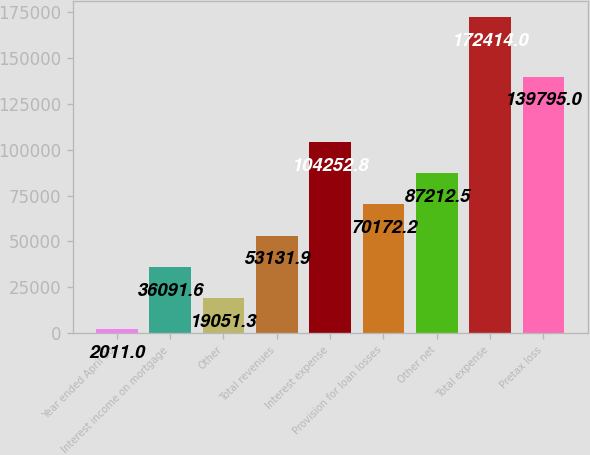Convert chart. <chart><loc_0><loc_0><loc_500><loc_500><bar_chart><fcel>Year ended April 30<fcel>Interest income on mortgage<fcel>Other<fcel>Total revenues<fcel>Interest expense<fcel>Provision for loan losses<fcel>Other net<fcel>Total expense<fcel>Pretax loss<nl><fcel>2011<fcel>36091.6<fcel>19051.3<fcel>53131.9<fcel>104253<fcel>70172.2<fcel>87212.5<fcel>172414<fcel>139795<nl></chart> 